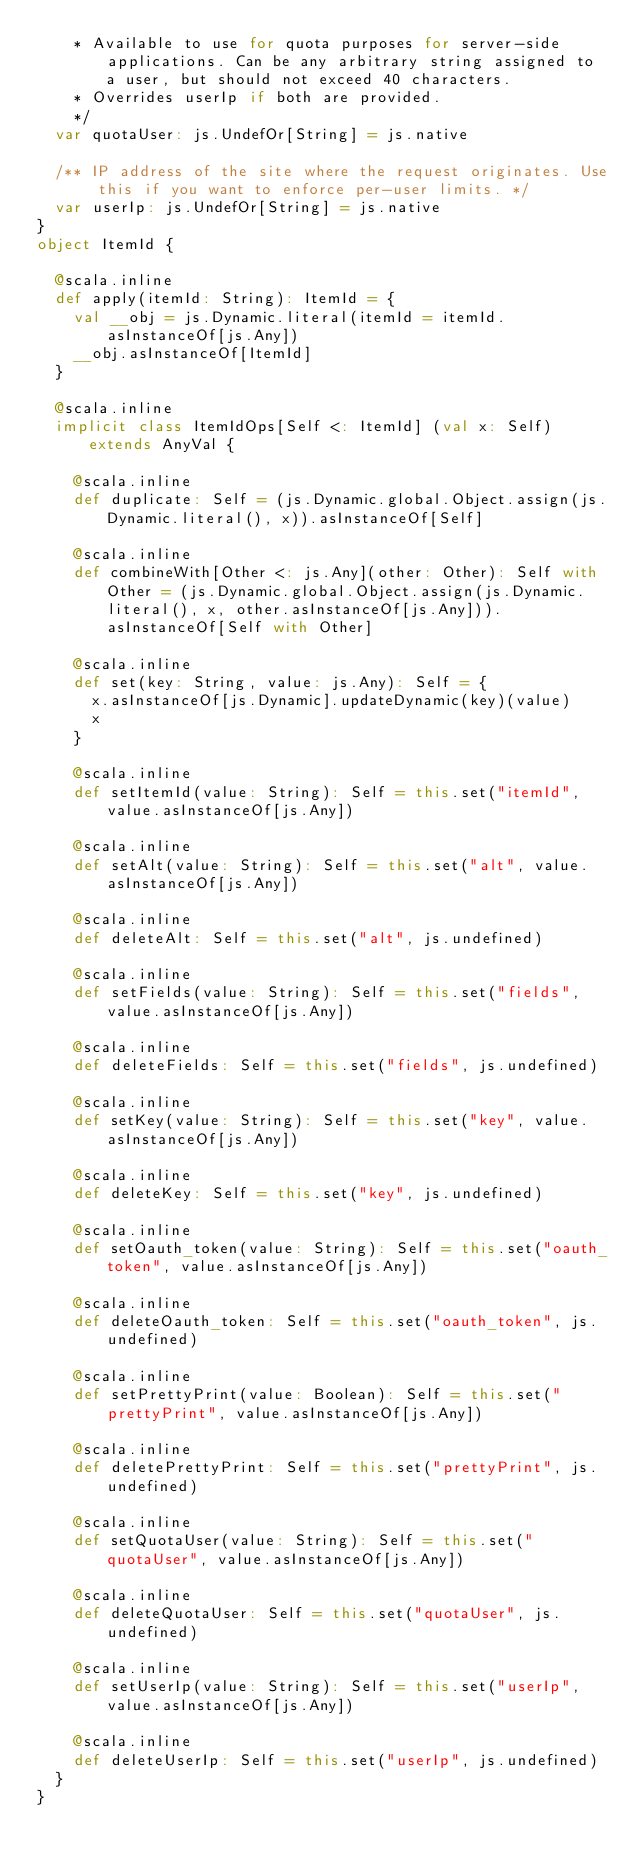Convert code to text. <code><loc_0><loc_0><loc_500><loc_500><_Scala_>    * Available to use for quota purposes for server-side applications. Can be any arbitrary string assigned to a user, but should not exceed 40 characters.
    * Overrides userIp if both are provided.
    */
  var quotaUser: js.UndefOr[String] = js.native
  
  /** IP address of the site where the request originates. Use this if you want to enforce per-user limits. */
  var userIp: js.UndefOr[String] = js.native
}
object ItemId {
  
  @scala.inline
  def apply(itemId: String): ItemId = {
    val __obj = js.Dynamic.literal(itemId = itemId.asInstanceOf[js.Any])
    __obj.asInstanceOf[ItemId]
  }
  
  @scala.inline
  implicit class ItemIdOps[Self <: ItemId] (val x: Self) extends AnyVal {
    
    @scala.inline
    def duplicate: Self = (js.Dynamic.global.Object.assign(js.Dynamic.literal(), x)).asInstanceOf[Self]
    
    @scala.inline
    def combineWith[Other <: js.Any](other: Other): Self with Other = (js.Dynamic.global.Object.assign(js.Dynamic.literal(), x, other.asInstanceOf[js.Any])).asInstanceOf[Self with Other]
    
    @scala.inline
    def set(key: String, value: js.Any): Self = {
      x.asInstanceOf[js.Dynamic].updateDynamic(key)(value)
      x
    }
    
    @scala.inline
    def setItemId(value: String): Self = this.set("itemId", value.asInstanceOf[js.Any])
    
    @scala.inline
    def setAlt(value: String): Self = this.set("alt", value.asInstanceOf[js.Any])
    
    @scala.inline
    def deleteAlt: Self = this.set("alt", js.undefined)
    
    @scala.inline
    def setFields(value: String): Self = this.set("fields", value.asInstanceOf[js.Any])
    
    @scala.inline
    def deleteFields: Self = this.set("fields", js.undefined)
    
    @scala.inline
    def setKey(value: String): Self = this.set("key", value.asInstanceOf[js.Any])
    
    @scala.inline
    def deleteKey: Self = this.set("key", js.undefined)
    
    @scala.inline
    def setOauth_token(value: String): Self = this.set("oauth_token", value.asInstanceOf[js.Any])
    
    @scala.inline
    def deleteOauth_token: Self = this.set("oauth_token", js.undefined)
    
    @scala.inline
    def setPrettyPrint(value: Boolean): Self = this.set("prettyPrint", value.asInstanceOf[js.Any])
    
    @scala.inline
    def deletePrettyPrint: Self = this.set("prettyPrint", js.undefined)
    
    @scala.inline
    def setQuotaUser(value: String): Self = this.set("quotaUser", value.asInstanceOf[js.Any])
    
    @scala.inline
    def deleteQuotaUser: Self = this.set("quotaUser", js.undefined)
    
    @scala.inline
    def setUserIp(value: String): Self = this.set("userIp", value.asInstanceOf[js.Any])
    
    @scala.inline
    def deleteUserIp: Self = this.set("userIp", js.undefined)
  }
}
</code> 